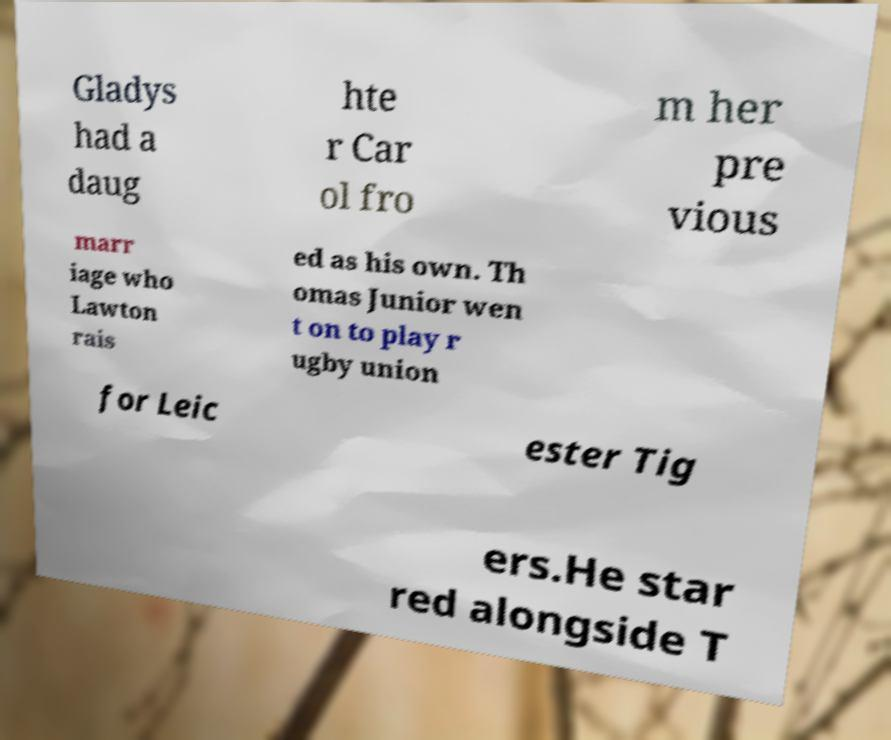What messages or text are displayed in this image? I need them in a readable, typed format. Gladys had a daug hte r Car ol fro m her pre vious marr iage who Lawton rais ed as his own. Th omas Junior wen t on to play r ugby union for Leic ester Tig ers.He star red alongside T 